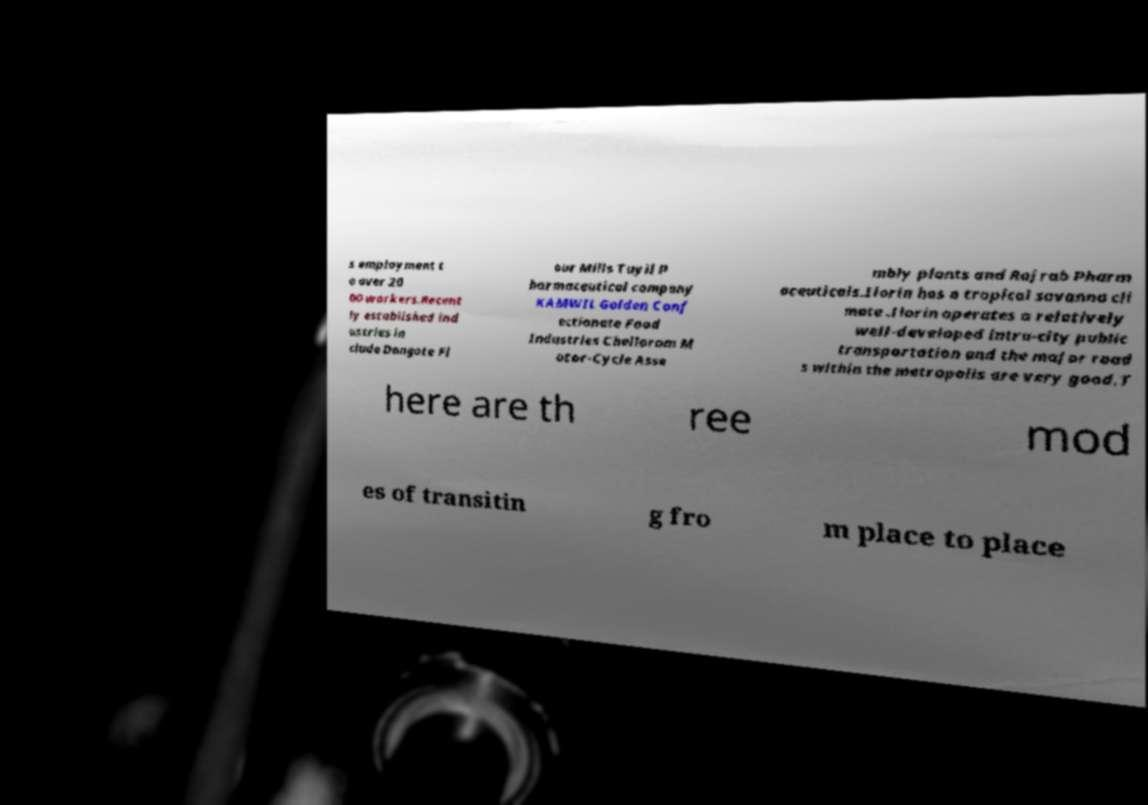Please read and relay the text visible in this image. What does it say? s employment t o over 20 00 workers.Recent ly established ind ustries in clude Dangote Fl our Mills Tuyil P harmaceutical company KAMWIL Golden Conf ectionate Food Industries Chellaram M otor-Cycle Asse mbly plants and Rajrab Pharm aceuticals.Ilorin has a tropical savanna cli mate .Ilorin operates a relatively well-developed intra-city public transportation and the major road s within the metropolis are very good.T here are th ree mod es of transitin g fro m place to place 